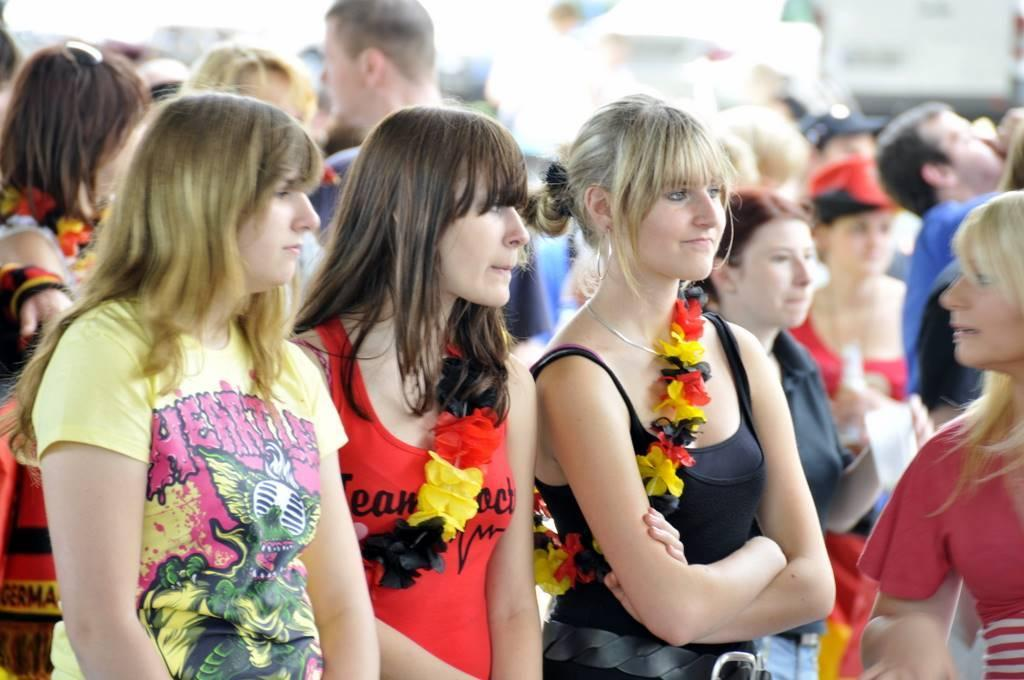What is the main subject of the image? The main subject of the image is a group of people. What are the people in the image doing? The people are standing. What can be observed about the people's clothing in the image? The people are wearing different color dresses. How would you describe the background of the image? The background of the image is blurred. What type of trail can be seen in the image? There is no trail present in the image; it features a group of people standing and wearing different color dresses. What health benefits are associated with the back of the image? There is no back or health benefits mentioned in the image; it focuses on a group of people standing and wearing different color dresses with a blurred background. 